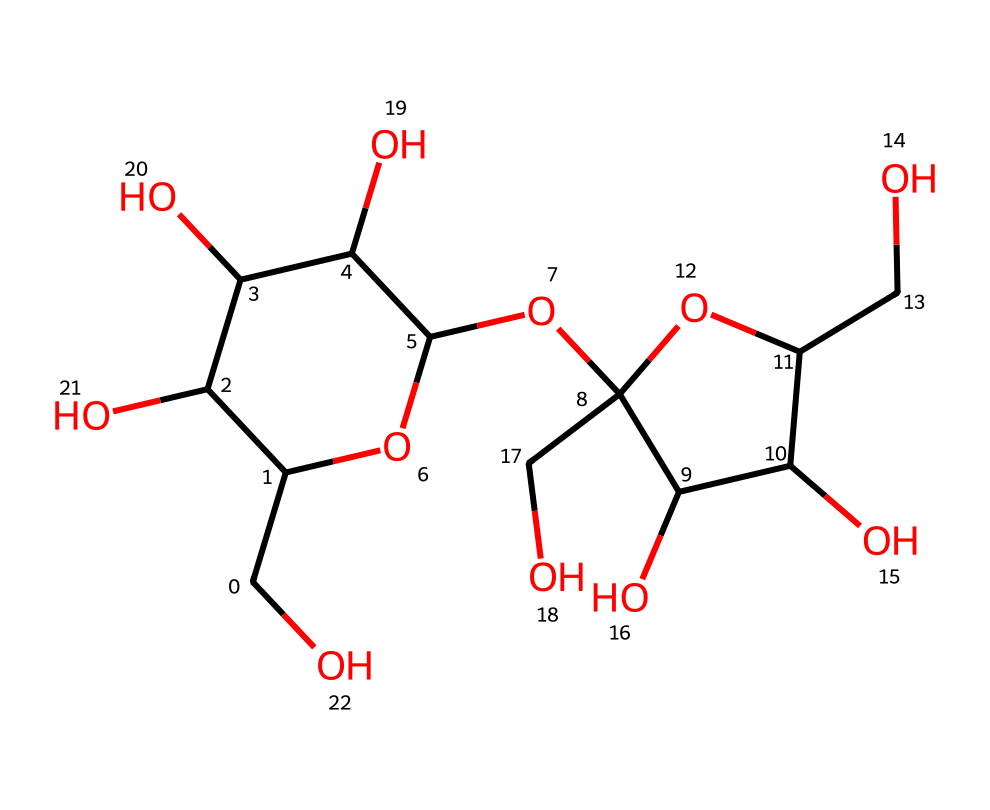What is the chemical name of this compound? The provided SMILES represents sucrose, which is commonly known as table sugar. It consists of two monosaccharides, glucose and fructose, linked together.
Answer: sucrose How many carbon atoms are present in this structure? By analyzing the SMILES, we can identify that there are 12 carbon atoms present in the sucrose structure. Each 'C' in the SMILES corresponds to a carbon atom.
Answer: 12 Is this compound soluble in water? Sucrose, being a non-electrolyte, is highly soluble in water due to its ability to form hydrogen bonds.
Answer: Yes What is the primary functional group in sucrose? The primary functional group present in sucrose is hydroxyl groups (-OH), which are responsible for many of its chemical properties. There are multiple -OH groups in the structure.
Answer: hydroxyl group How many oxygen atoms are in this molecule? By counting the number of 'O' characters in the SMILES representation, it's clear that there are 6 oxygen atoms in the sucrose structure.
Answer: 6 Does sucrose dissociate in solution? Sucrose is classified as a non-electrolyte, meaning it does not dissociate into ions when dissolved in water. It retains its molecular structure.
Answer: No What type of bond primarily stabilizes the structure of sucrose? The structure of sucrose is primarily stabilized by covalent bonds between carbon, hydrogen, and oxygen atoms, which hold the molecule together.
Answer: covalent bonds 